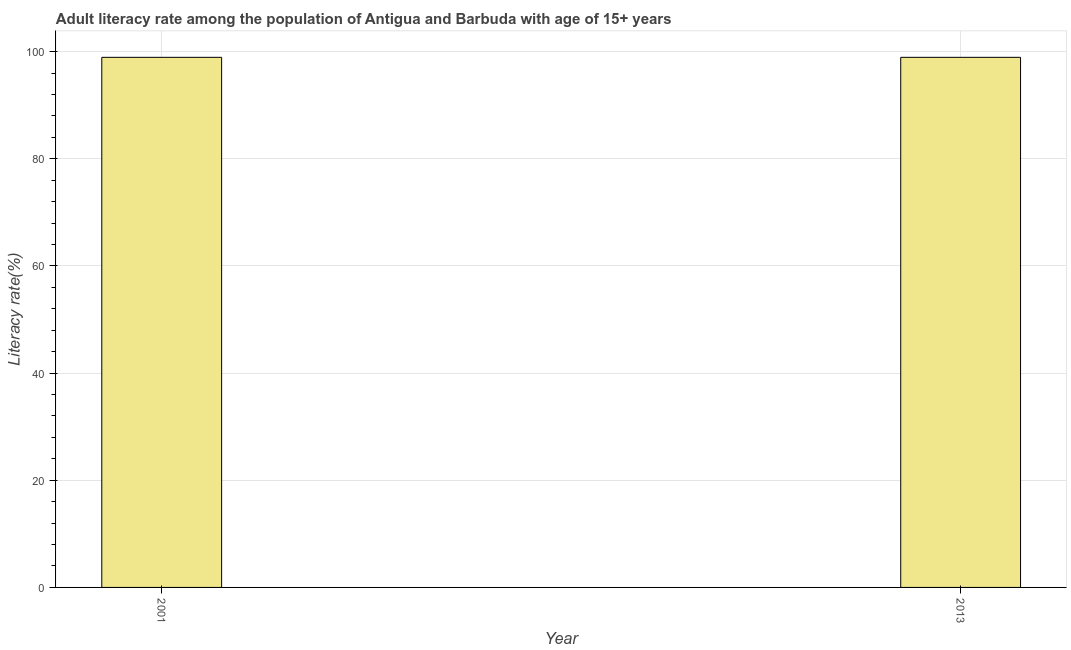Does the graph contain any zero values?
Provide a succinct answer. No. Does the graph contain grids?
Your response must be concise. Yes. What is the title of the graph?
Your answer should be very brief. Adult literacy rate among the population of Antigua and Barbuda with age of 15+ years. What is the label or title of the Y-axis?
Offer a terse response. Literacy rate(%). What is the adult literacy rate in 2001?
Keep it short and to the point. 98.95. Across all years, what is the maximum adult literacy rate?
Keep it short and to the point. 98.95. Across all years, what is the minimum adult literacy rate?
Provide a short and direct response. 98.95. What is the sum of the adult literacy rate?
Your response must be concise. 197.9. What is the average adult literacy rate per year?
Offer a very short reply. 98.95. What is the median adult literacy rate?
Your answer should be compact. 98.95. In how many years, is the adult literacy rate greater than 28 %?
Give a very brief answer. 2. What is the ratio of the adult literacy rate in 2001 to that in 2013?
Give a very brief answer. 1. In how many years, is the adult literacy rate greater than the average adult literacy rate taken over all years?
Provide a short and direct response. 0. What is the Literacy rate(%) in 2001?
Provide a short and direct response. 98.95. What is the Literacy rate(%) of 2013?
Ensure brevity in your answer.  98.95. What is the ratio of the Literacy rate(%) in 2001 to that in 2013?
Your response must be concise. 1. 